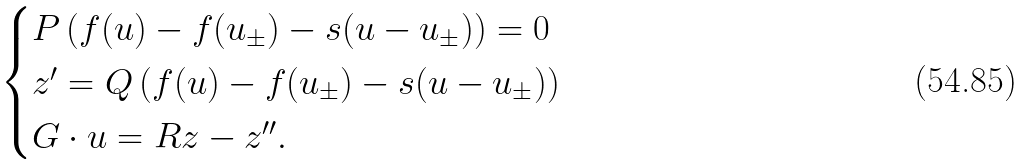<formula> <loc_0><loc_0><loc_500><loc_500>\begin{cases} P \left ( f ( u ) - f ( u _ { \pm } ) - s ( u - u _ { \pm } ) \right ) = 0 & \\ z ^ { \prime } = Q \left ( f ( u ) - f ( u _ { \pm } ) - s ( u - u _ { \pm } ) \right ) & \\ G \cdot u = R z - z ^ { \prime \prime } . & \end{cases}</formula> 